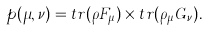<formula> <loc_0><loc_0><loc_500><loc_500>p ( \mu , \nu ) = t r ( \rho F _ { \mu } ) \times t r ( \rho _ { \mu } G _ { \nu } ) .</formula> 